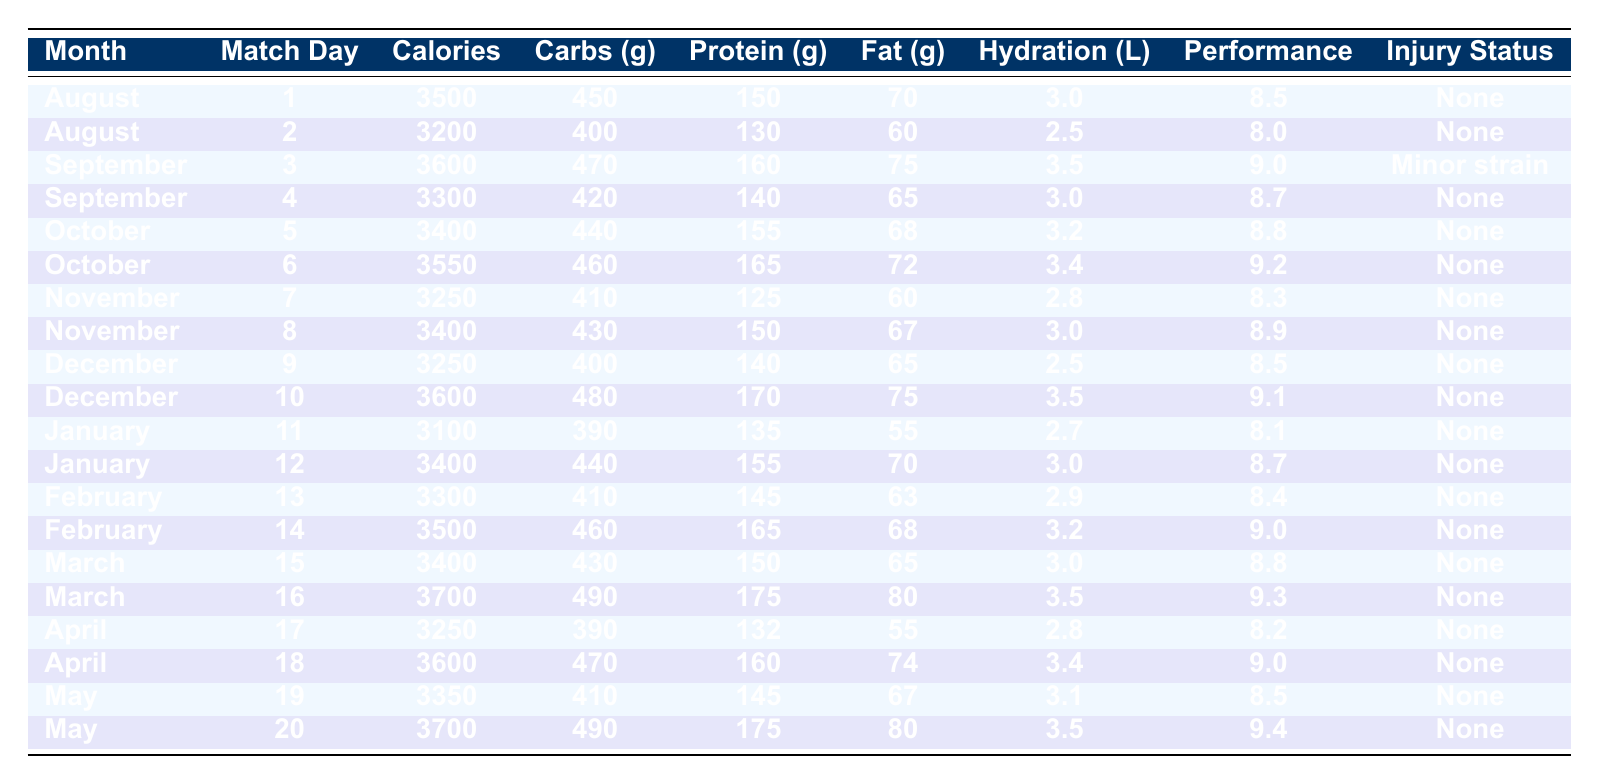What was the highest performance rating recorded in the table? The table lists performance ratings for each match day. Scanning through the ratings, the highest value is 9.4 noted in May, match day 20.
Answer: 9.4 What was the average calorie intake for the matches in January? There are two matches listed in January with calorie intakes of 3100 and 3400. Summing these (3100 + 3400) gives 6500, and dividing by 2 (because there are 2 matches) results in an average of 3250 calories.
Answer: 3250 How many matches recorded a performance rating of 9.0 or higher? The table indicates a performance rating of 9.0 or higher for September match day 3, October match day 6, February match day 14, March match day 16, and May match day 20. Counting these gives a total of 5 matches.
Answer: 5 Is there any month where all matches recorded a performance rating below 9.0? Looking at each month, November show performance ratings of 8.3 and 8.9, while December shows ratings of 8.5 and 9.1, October ratings are also 8.8 and 9.2. Thus, indeed November is the only month where all match ratings are below 9.0.
Answer: Yes What is the total carbohydrate intake for matches played in February? In February, matches have carbohydrate intakes of 410 and 460 grams. Adding these values together yields a total of 870 grams for February.
Answer: 870 What is the monthly average performance rating across the season? To find the monthly average, we sum the performance ratings across all months (8.5 + 8.0 + 9.0 + ... + 9.4) which totals to 170. Dividing this by the number of matches (20) results in an average performance rating of 8.5.
Answer: 8.5 How many times did hydration levels fall below 3 liters? Checking the hydration levels for each match day, the levels below 3 liters occur in August match day 2, November match day 7, December match day 9, and January match day 11. This totals to 4 times.
Answer: 4 What is the difference in performance rating between the highest and lowest value recorded? The highest performance rating recorded is 9.4 (May match day 20) and the lowest is 8.0 (August match day 2). The difference (9.4 - 8.0) results in 1.4.
Answer: 1.4 How did the calorie intake change from August match day 1 to May match day 20? The calorie intake in August match day 1 was 3500 calories and in May match day 20 it was 3700 calories. Calculating the change (3700 - 3500), shows an increase of 200 calories from August to May.
Answer: 200 What percentage of matches had an injury status reported as "none"? There are 20 total matches, and only 1 match in September had an injury status of "minor strain", meaning 19 matches had an injury status of "none". To find the percentage, (19 / 20) × 100 = 95%.
Answer: 95% 